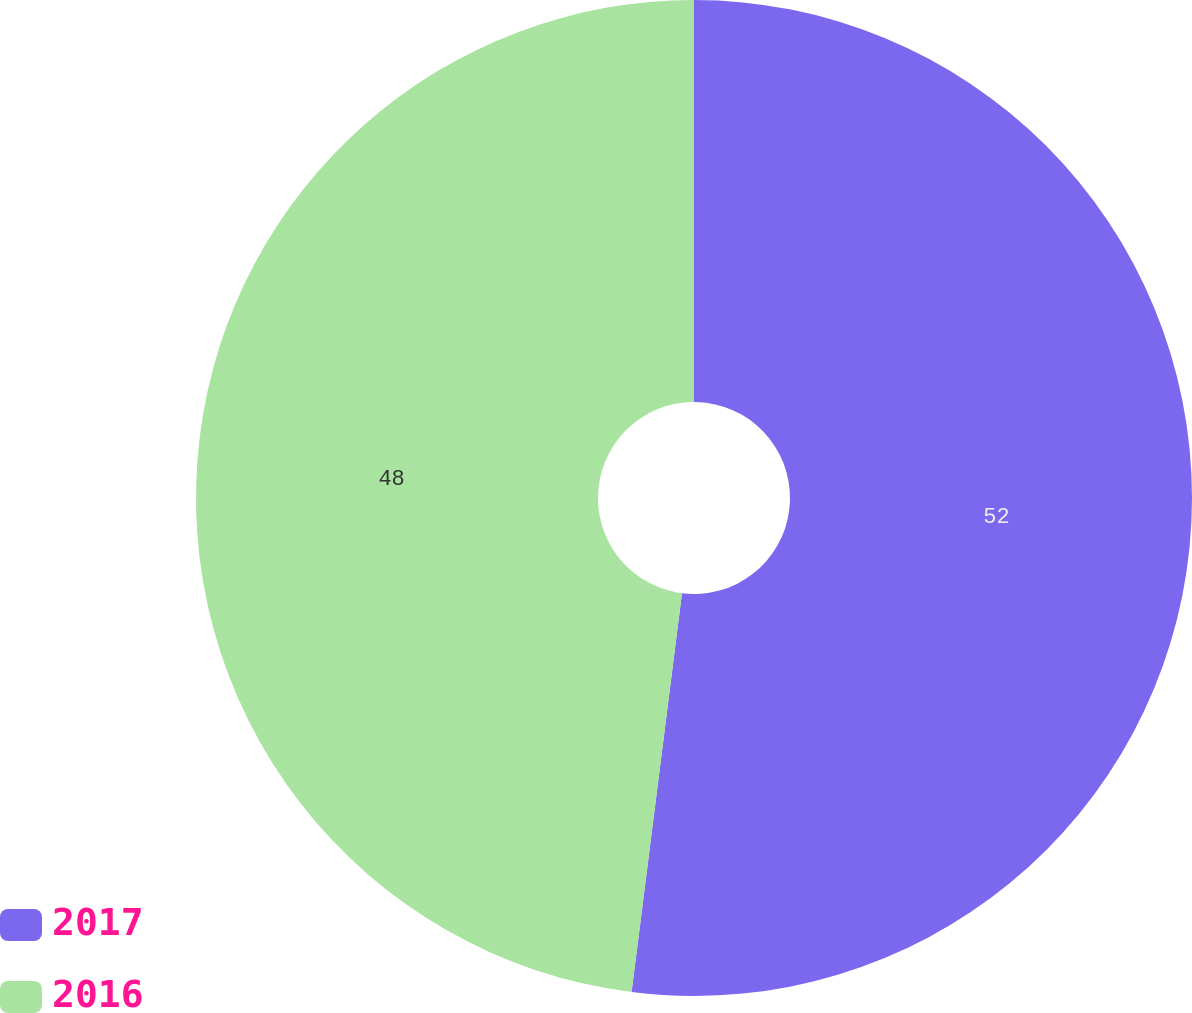Convert chart to OTSL. <chart><loc_0><loc_0><loc_500><loc_500><pie_chart><fcel>2017<fcel>2016<nl><fcel>52.0%<fcel>48.0%<nl></chart> 